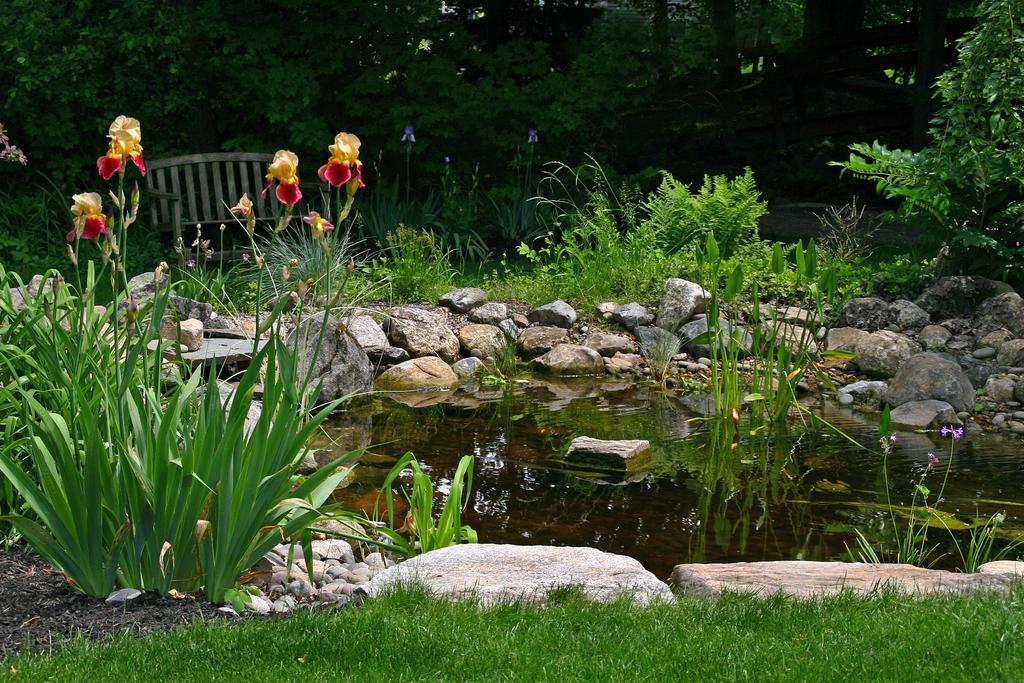What is the main feature in the center of the image? There is a pond in the center of the image. What type of natural elements can be seen in the image? There are rocks, grass, plants, and trees visible in the image. Where is the grass located in the image? There is grass at the bottom of the image. What is in the background of the image? There are trees and a bench in the background of the image. How many lizards can be seen crawling on the bench in the image? There are no lizards present in the image; the bench is empty. What country is the pond located in, based on the image? The image does not provide any information about the country where the pond is located. 